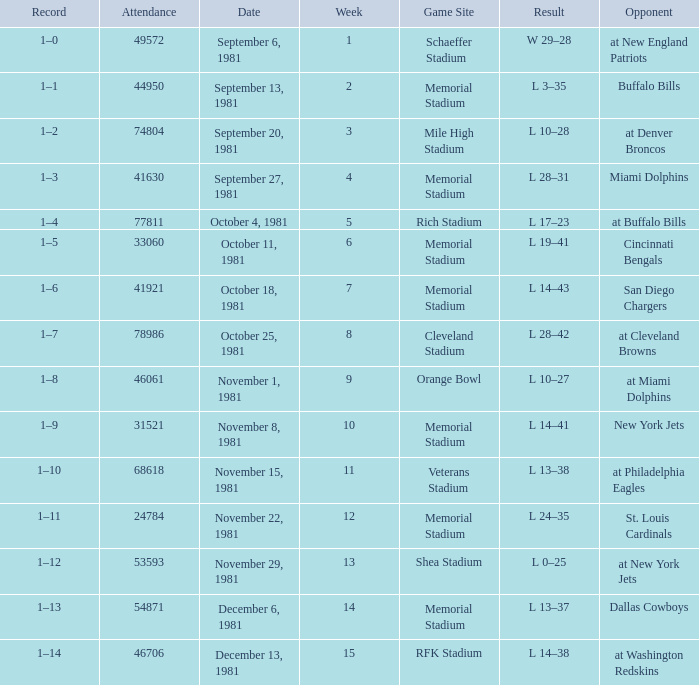When it is week 2 what is the record? 1–1. 